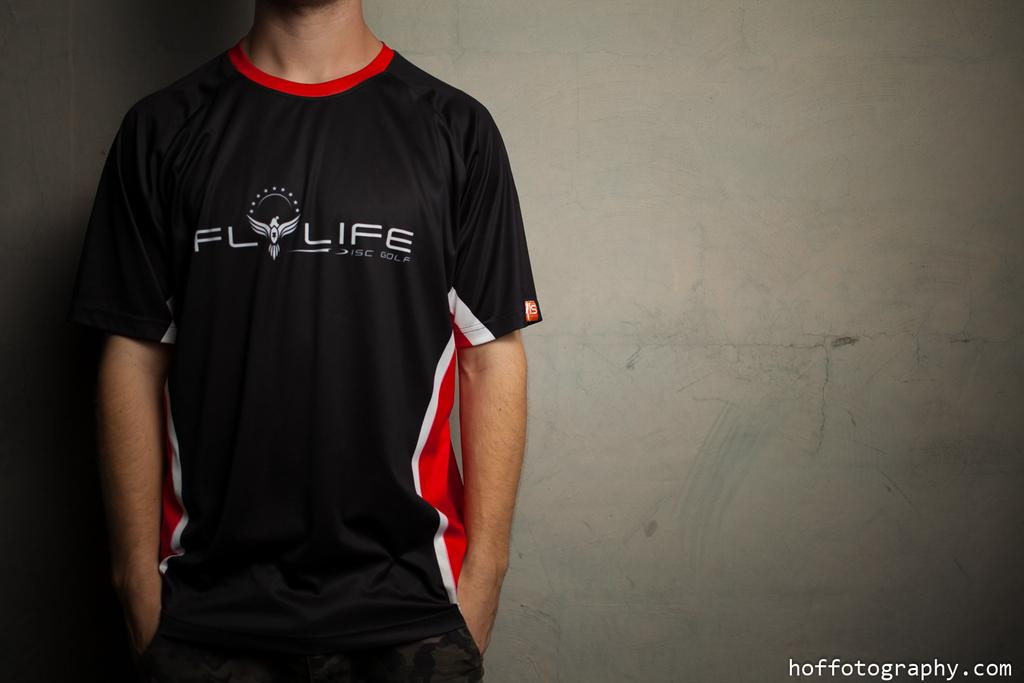<image>
Write a terse but informative summary of the picture. a man wearing a black shirt that says Flylife 